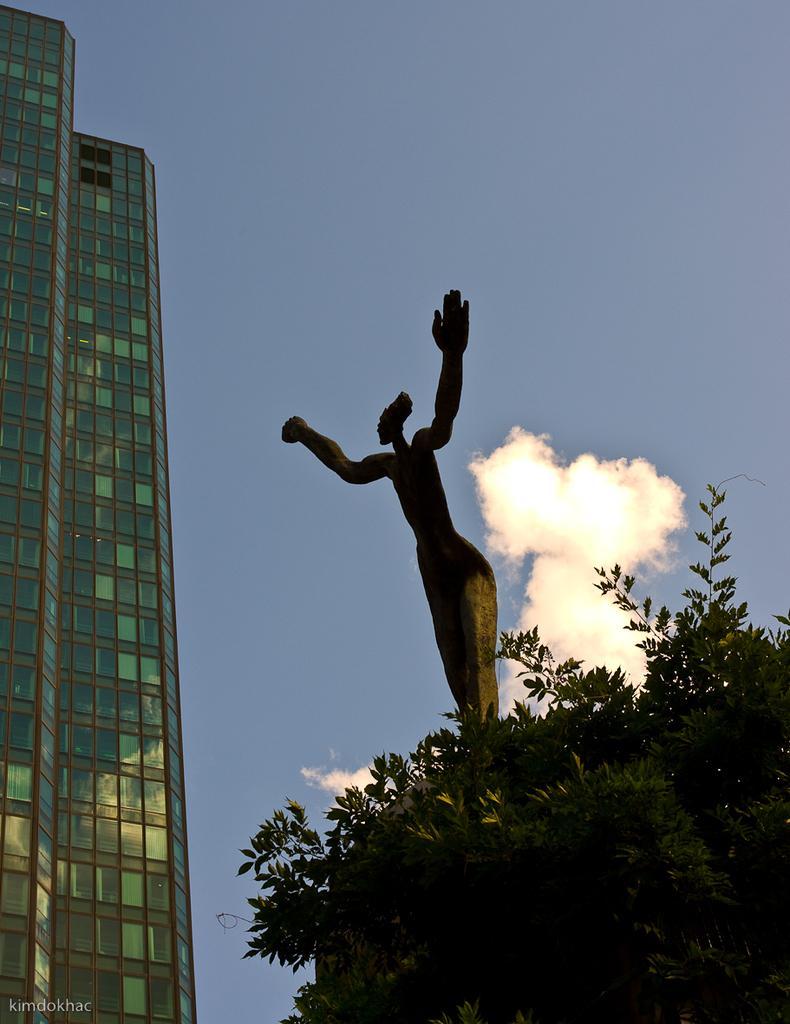Can you describe this image briefly? In this image we can see a building on the left side of the image and there is a statue. We can see a tree and at the top there is a sky. 